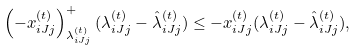<formula> <loc_0><loc_0><loc_500><loc_500>\left ( - x _ { i J j } ^ { ( t ) } \right ) ^ { + } _ { \lambda _ { i J j } ^ { ( t ) } } ( \lambda _ { i J j } ^ { ( t ) } - \hat { \lambda } _ { i J j } ^ { ( t ) } ) \leq - x _ { i J j } ^ { ( t ) } ( \lambda _ { i J j } ^ { ( t ) } - \hat { \lambda } _ { i J j } ^ { ( t ) } ) ,</formula> 